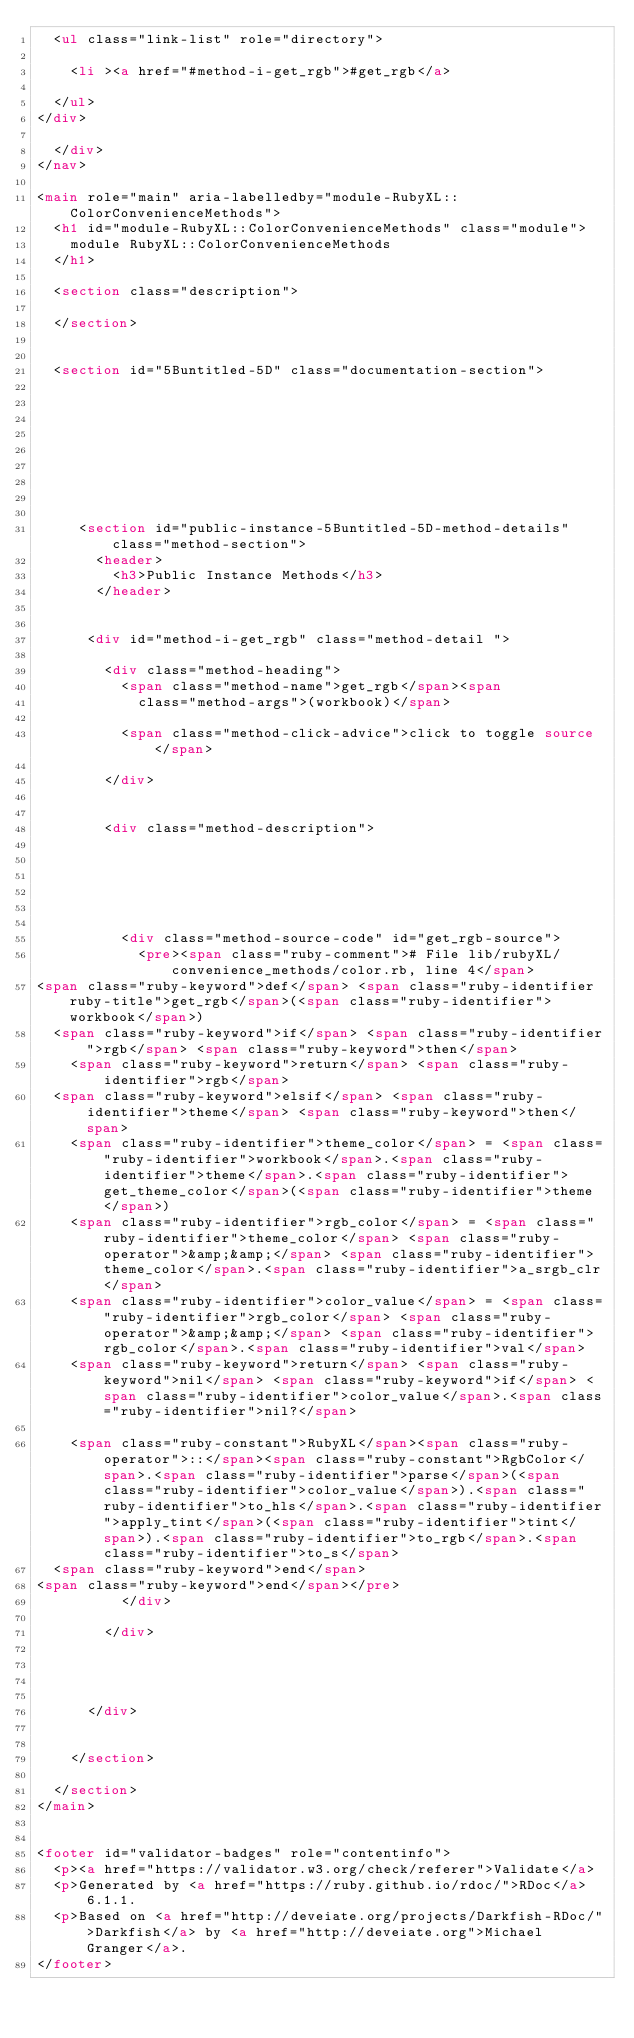Convert code to text. <code><loc_0><loc_0><loc_500><loc_500><_HTML_>  <ul class="link-list" role="directory">
    
    <li ><a href="#method-i-get_rgb">#get_rgb</a>
    
  </ul>
</div>

  </div>
</nav>

<main role="main" aria-labelledby="module-RubyXL::ColorConvenienceMethods">
  <h1 id="module-RubyXL::ColorConvenienceMethods" class="module">
    module RubyXL::ColorConvenienceMethods
  </h1>

  <section class="description">
    
  </section>

  
  <section id="5Buntitled-5D" class="documentation-section">
    

    

    

    

    
     <section id="public-instance-5Buntitled-5D-method-details" class="method-section">
       <header>
         <h3>Public Instance Methods</h3>
       </header>

    
      <div id="method-i-get_rgb" class="method-detail ">
        
        <div class="method-heading">
          <span class="method-name">get_rgb</span><span
            class="method-args">(workbook)</span>
          
          <span class="method-click-advice">click to toggle source</span>
          
        </div>
        

        <div class="method-description">
          
          
          
          

          
          <div class="method-source-code" id="get_rgb-source">
            <pre><span class="ruby-comment"># File lib/rubyXL/convenience_methods/color.rb, line 4</span>
<span class="ruby-keyword">def</span> <span class="ruby-identifier ruby-title">get_rgb</span>(<span class="ruby-identifier">workbook</span>)
  <span class="ruby-keyword">if</span> <span class="ruby-identifier">rgb</span> <span class="ruby-keyword">then</span>
    <span class="ruby-keyword">return</span> <span class="ruby-identifier">rgb</span>
  <span class="ruby-keyword">elsif</span> <span class="ruby-identifier">theme</span> <span class="ruby-keyword">then</span>
    <span class="ruby-identifier">theme_color</span> = <span class="ruby-identifier">workbook</span>.<span class="ruby-identifier">theme</span>.<span class="ruby-identifier">get_theme_color</span>(<span class="ruby-identifier">theme</span>)
    <span class="ruby-identifier">rgb_color</span> = <span class="ruby-identifier">theme_color</span> <span class="ruby-operator">&amp;&amp;</span> <span class="ruby-identifier">theme_color</span>.<span class="ruby-identifier">a_srgb_clr</span>
    <span class="ruby-identifier">color_value</span> = <span class="ruby-identifier">rgb_color</span> <span class="ruby-operator">&amp;&amp;</span> <span class="ruby-identifier">rgb_color</span>.<span class="ruby-identifier">val</span>
    <span class="ruby-keyword">return</span> <span class="ruby-keyword">nil</span> <span class="ruby-keyword">if</span> <span class="ruby-identifier">color_value</span>.<span class="ruby-identifier">nil?</span>

    <span class="ruby-constant">RubyXL</span><span class="ruby-operator">::</span><span class="ruby-constant">RgbColor</span>.<span class="ruby-identifier">parse</span>(<span class="ruby-identifier">color_value</span>).<span class="ruby-identifier">to_hls</span>.<span class="ruby-identifier">apply_tint</span>(<span class="ruby-identifier">tint</span>).<span class="ruby-identifier">to_rgb</span>.<span class="ruby-identifier">to_s</span>
  <span class="ruby-keyword">end</span>
<span class="ruby-keyword">end</span></pre>
          </div>
          
        </div>

        

        
      </div>

    
    </section>
  
  </section>
</main>


<footer id="validator-badges" role="contentinfo">
  <p><a href="https://validator.w3.org/check/referer">Validate</a>
  <p>Generated by <a href="https://ruby.github.io/rdoc/">RDoc</a> 6.1.1.
  <p>Based on <a href="http://deveiate.org/projects/Darkfish-RDoc/">Darkfish</a> by <a href="http://deveiate.org">Michael Granger</a>.
</footer>

</code> 